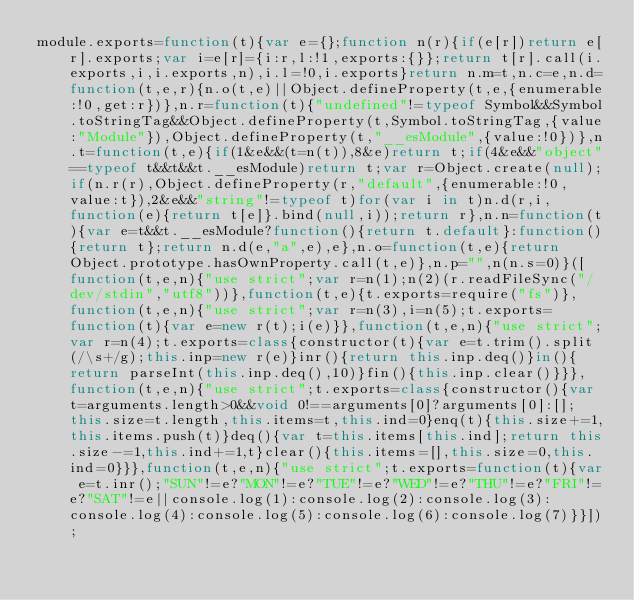<code> <loc_0><loc_0><loc_500><loc_500><_JavaScript_>module.exports=function(t){var e={};function n(r){if(e[r])return e[r].exports;var i=e[r]={i:r,l:!1,exports:{}};return t[r].call(i.exports,i,i.exports,n),i.l=!0,i.exports}return n.m=t,n.c=e,n.d=function(t,e,r){n.o(t,e)||Object.defineProperty(t,e,{enumerable:!0,get:r})},n.r=function(t){"undefined"!=typeof Symbol&&Symbol.toStringTag&&Object.defineProperty(t,Symbol.toStringTag,{value:"Module"}),Object.defineProperty(t,"__esModule",{value:!0})},n.t=function(t,e){if(1&e&&(t=n(t)),8&e)return t;if(4&e&&"object"==typeof t&&t&&t.__esModule)return t;var r=Object.create(null);if(n.r(r),Object.defineProperty(r,"default",{enumerable:!0,value:t}),2&e&&"string"!=typeof t)for(var i in t)n.d(r,i,function(e){return t[e]}.bind(null,i));return r},n.n=function(t){var e=t&&t.__esModule?function(){return t.default}:function(){return t};return n.d(e,"a",e),e},n.o=function(t,e){return Object.prototype.hasOwnProperty.call(t,e)},n.p="",n(n.s=0)}([function(t,e,n){"use strict";var r=n(1);n(2)(r.readFileSync("/dev/stdin","utf8"))},function(t,e){t.exports=require("fs")},function(t,e,n){"use strict";var r=n(3),i=n(5);t.exports=function(t){var e=new r(t);i(e)}},function(t,e,n){"use strict";var r=n(4);t.exports=class{constructor(t){var e=t.trim().split(/\s+/g);this.inp=new r(e)}inr(){return this.inp.deq()}in(){return parseInt(this.inp.deq(),10)}fin(){this.inp.clear()}}},function(t,e,n){"use strict";t.exports=class{constructor(){var t=arguments.length>0&&void 0!==arguments[0]?arguments[0]:[];this.size=t.length,this.items=t,this.ind=0}enq(t){this.size+=1,this.items.push(t)}deq(){var t=this.items[this.ind];return this.size-=1,this.ind+=1,t}clear(){this.items=[],this.size=0,this.ind=0}}},function(t,e,n){"use strict";t.exports=function(t){var e=t.inr();"SUN"!=e?"MON"!=e?"TUE"!=e?"WED"!=e?"THU"!=e?"FRI"!=e?"SAT"!=e||console.log(1):console.log(2):console.log(3):console.log(4):console.log(5):console.log(6):console.log(7)}}]);
</code> 